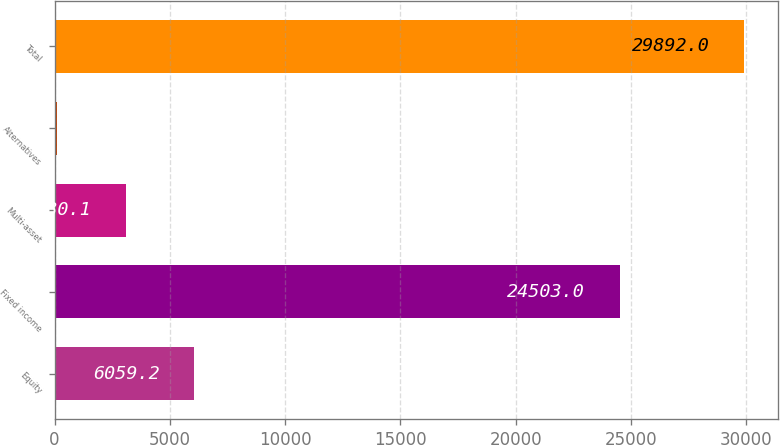Convert chart to OTSL. <chart><loc_0><loc_0><loc_500><loc_500><bar_chart><fcel>Equity<fcel>Fixed income<fcel>Multi-asset<fcel>Alternatives<fcel>Total<nl><fcel>6059.2<fcel>24503<fcel>3080.1<fcel>101<fcel>29892<nl></chart> 